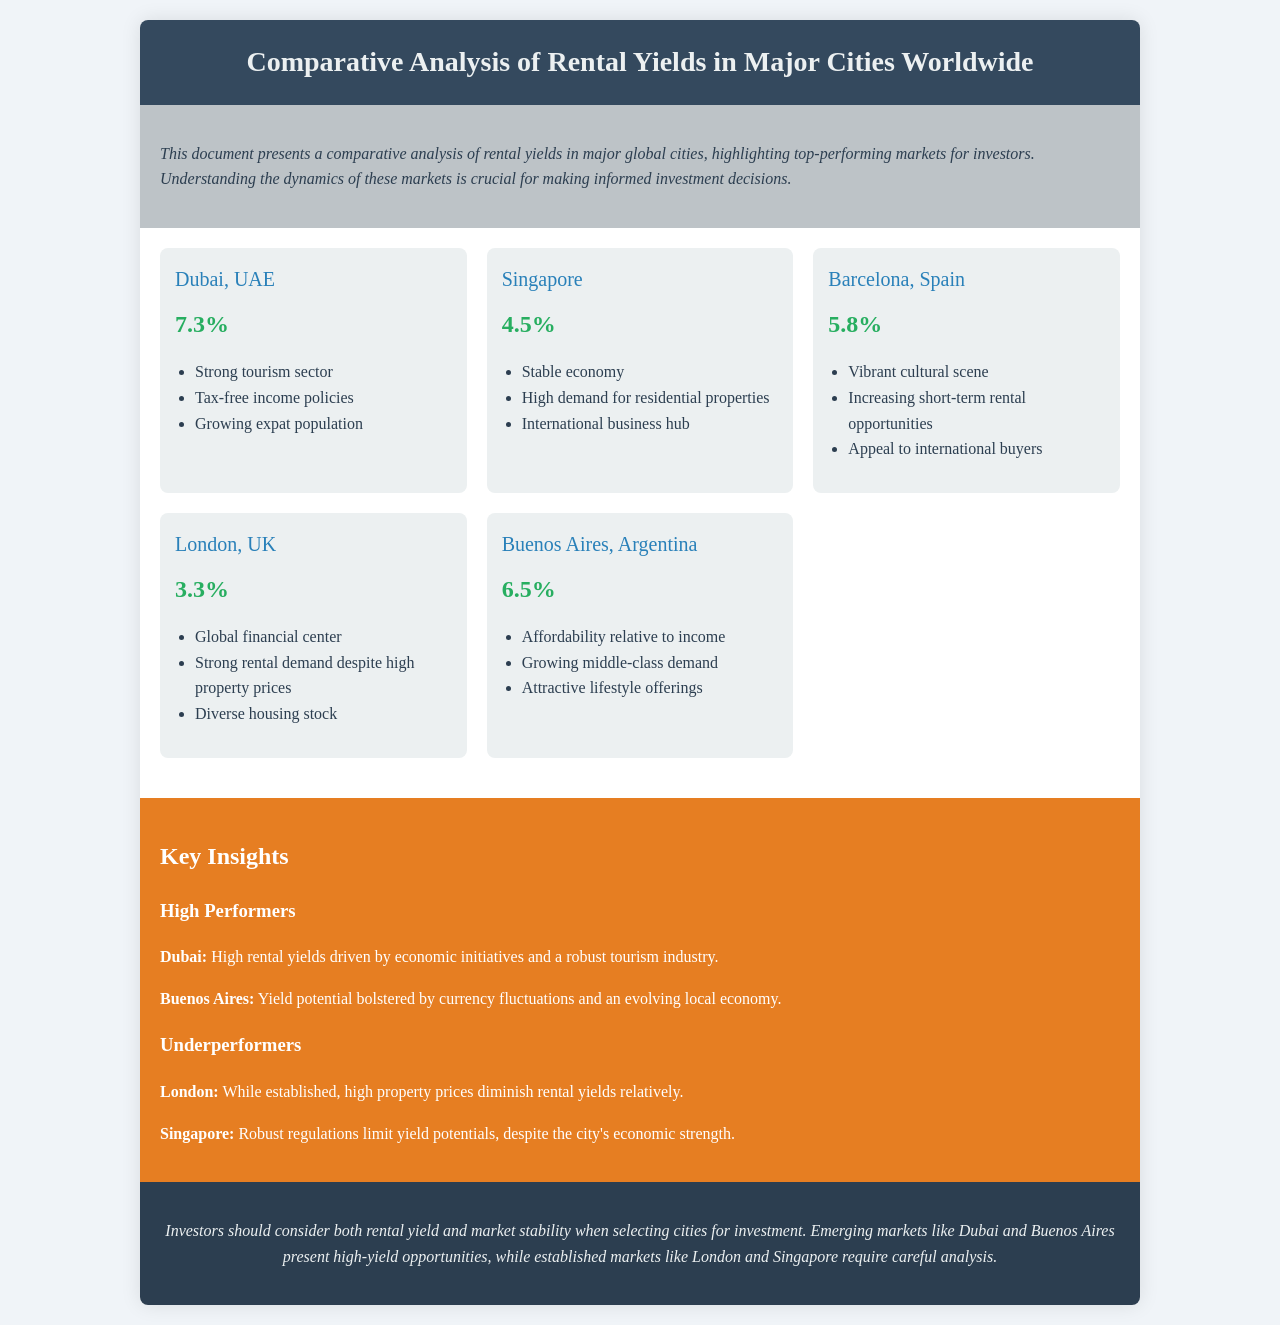What city has the highest rental yield? The document states that Dubai has the highest rental yield among the listed cities, at 7.3%.
Answer: Dubai What is the rental yield for London? The document specifically mentions that the rental yield for London is 3.3%.
Answer: 3.3% Which city shows a significant potential due to currency fluctuations? The document indicates that Buenos Aires' yield potential is bolstered by currency fluctuations.
Answer: Buenos Aires What is one advantage of investing in Dubai? The document highlights that Dubai benefits from a strong tourism sector and tax-free income policies.
Answer: Strong tourism sector Which two cities are mentioned as underperformers? The document lists London and Singapore as underperformers in rental yields.
Answer: London, Singapore What is a key reason for Singapore's limited yield potential? The document notes that robust regulations limit yield potentials in Singapore despite its economic strength.
Answer: Robust regulations What is the rental yield for Barcelona? The document specifies that Barcelona has a rental yield of 5.8%.
Answer: 5.8% Which market is described as having high-yield opportunities? The document suggests that emerging markets like Dubai and Buenos Aires present high-yield opportunities.
Answer: Dubai, Buenos Aires 